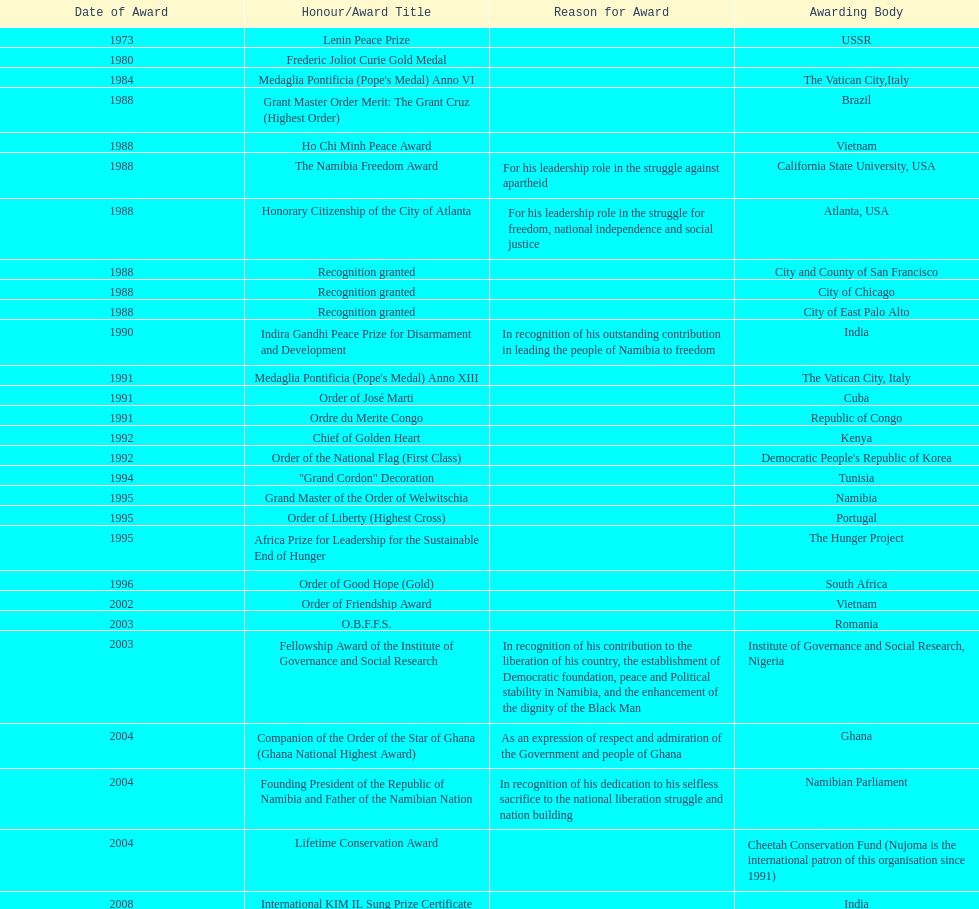Which year was the most honors/award titles given? 1988. 